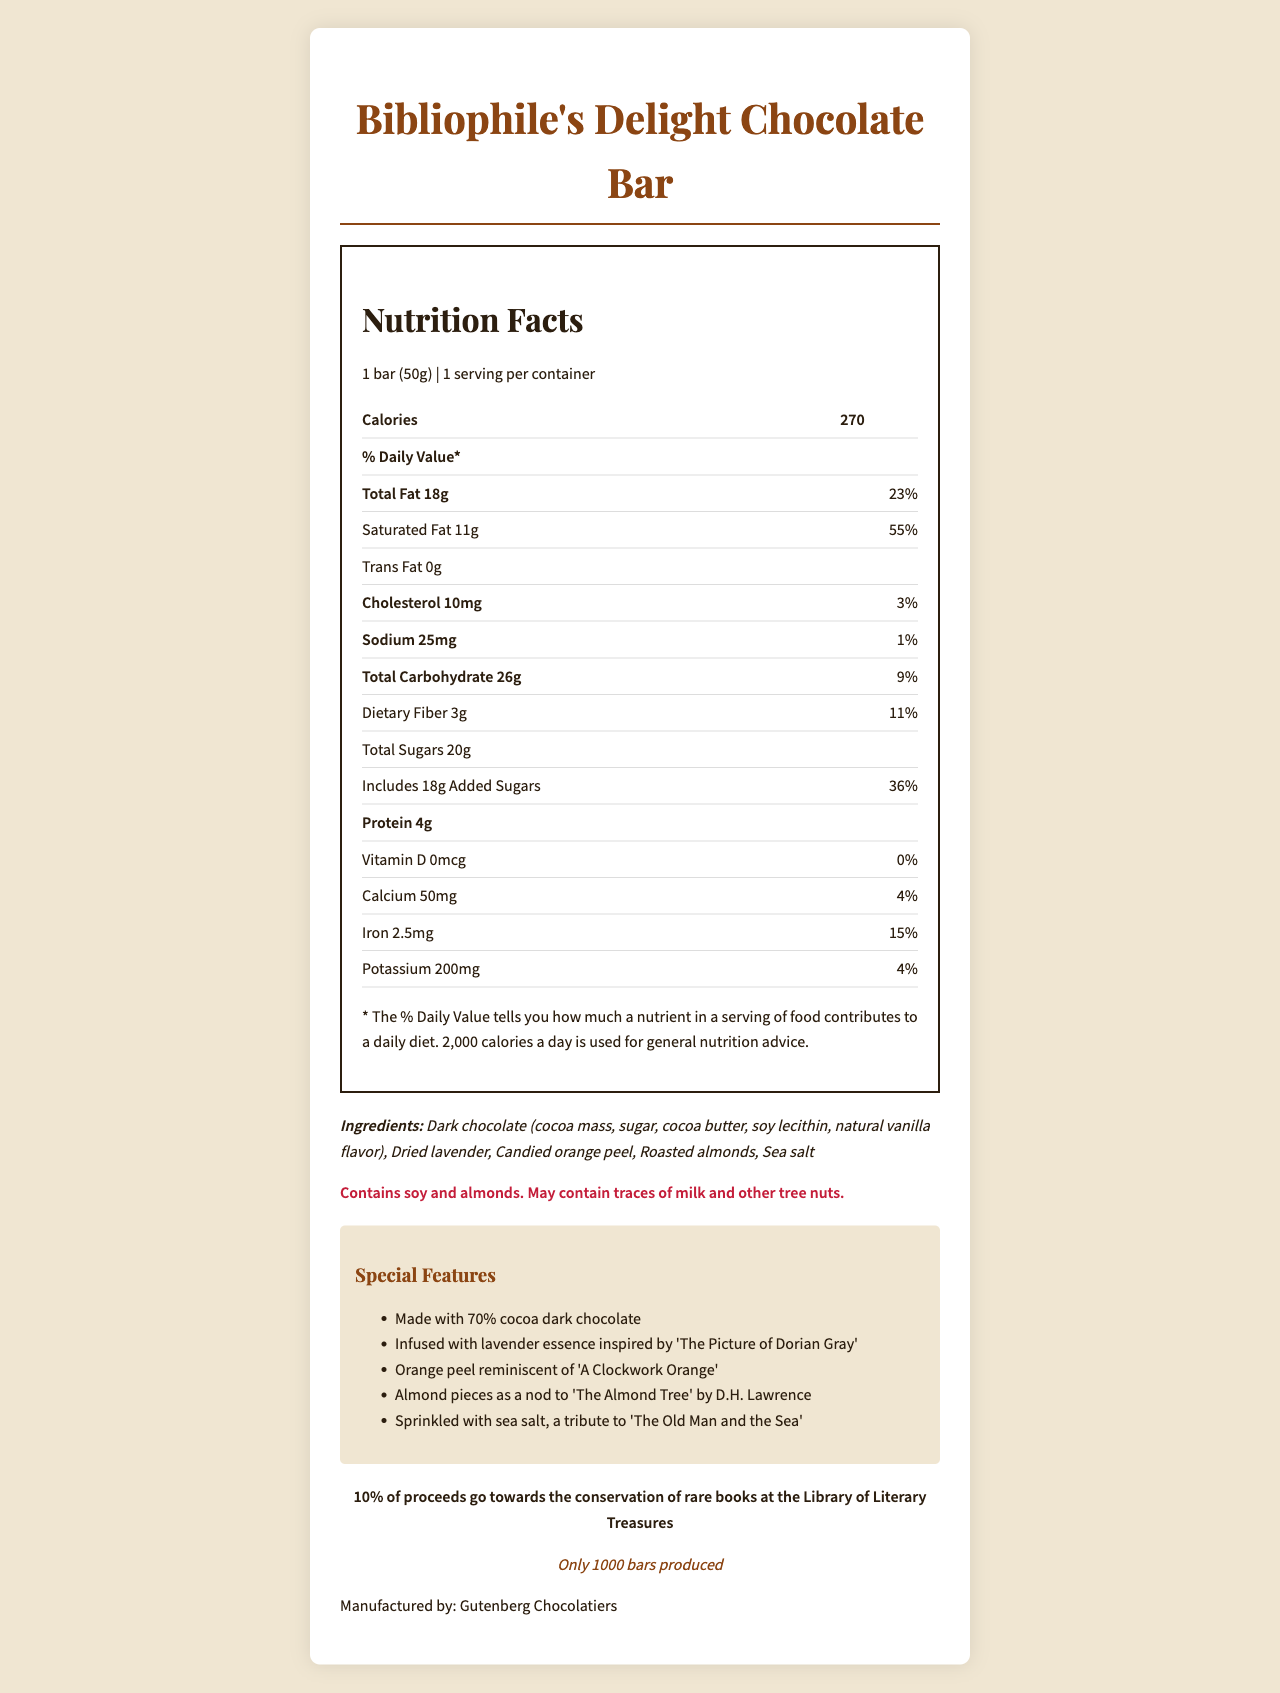what is the name of the product? The name of the product is displayed prominently at the top of the document.
Answer: Bibliophile's Delight Chocolate Bar what is the serving size of the chocolate bar? The serving size information is listed under the "Nutrition Facts" section as "1 bar (50g)".
Answer: 1 bar (50g) how many calories are in one serving of the chocolate bar? The calorie content per serving is indicated in the "Nutrition Facts" section as 270.
Answer: 270 calories which ingredients are included in the chocolate bar? The ingredients are listed under the "Ingredients" section in the document.
Answer: Dark chocolate, Dried lavender, Candied orange peel, Roasted almonds, Sea salt what percentage of daily value of saturated fat does one serving contain? The saturated fat daily value percentage is indicated as 55% in the "Nutrition Facts" table.
Answer: 55% how many grams of protein are in one serving of the chocolate bar? The protein content per serving is listed as 4g in the "Nutrition Facts" section.
Answer: 4g what are the allergens listed for the chocolate bar? The allergens are provided under the "Allergens" section in the document.
Answer: Contains soy and almonds. May contain traces of milk and other tree nuts. how many bars were produced for this limited edition? The number of bars produced is listed under the "limited-edition" section as 1000.
Answer: 1000 bars how much calcium does one serving of the chocolate bar provide? A. 50mg B. 100mg C. 150mg D. 200mg The calcium content is listed as 50mg in the "Nutrition Facts" section.
Answer: A. 50mg which feature is inspired by 'The Old Man and the Sea'? A. Dark chocolate B. Lavender essence C. Orange peel D. Sea salt The special features list indicates that "sea salt, a tribute to 'The Old Man and the Sea'" is included.
Answer: D. Sea salt does the chocolate bar contain any trans fat? The "Nutrition Facts" section lists trans fat content as 0g, indicating that the chocolate bar does not contain any trans fat.
Answer: No is the chocolate bar made with milk chocolate? The document specifies the ingredients as "Dark chocolate," and it does not mention milk chocolate.
Answer: No summarize the main idea of this document. The document is a comprehensive overview of the chocolate bar's nutritional facts, unique features inspired by literary works, and details of its role in supporting a fundraising effort.
Answer: The document provides detailed nutritional information, ingredient list, and allergen warnings for the "Bibliophile's Delight Chocolate Bar," a limited-edition chocolate bar designed to pay tribute to various literary works. It also highlights that 10% of proceeds from the sales go towards the conservation of rare books at the Library of Literary Treasures. can i find out the price of the chocolate bar from this document? The document does not provide any information regarding the price of the chocolate bar.
Answer: Not enough information 